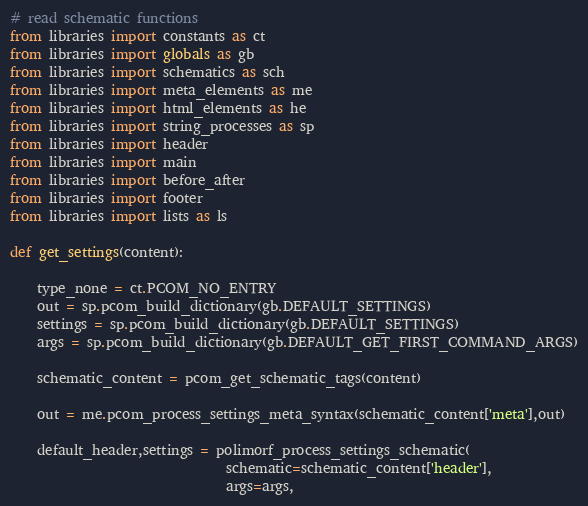<code> <loc_0><loc_0><loc_500><loc_500><_Python_># read schematic functions
from libraries import constants as ct
from libraries import globals as gb
from libraries import schematics as sch
from libraries import meta_elements as me
from libraries import html_elements as he
from libraries import string_processes as sp
from libraries import header
from libraries import main
from libraries import before_after
from libraries import footer
from libraries import lists as ls

def get_settings(content):

    type_none = ct.PCOM_NO_ENTRY
    out = sp.pcom_build_dictionary(gb.DEFAULT_SETTINGS)
    settings = sp.pcom_build_dictionary(gb.DEFAULT_SETTINGS)
    args = sp.pcom_build_dictionary(gb.DEFAULT_GET_FIRST_COMMAND_ARGS)

    schematic_content = pcom_get_schematic_tags(content)

    out = me.pcom_process_settings_meta_syntax(schematic_content['meta'],out)

    default_header,settings = polimorf_process_settings_schematic(
                                schematic=schematic_content['header'],
                                args=args,</code> 